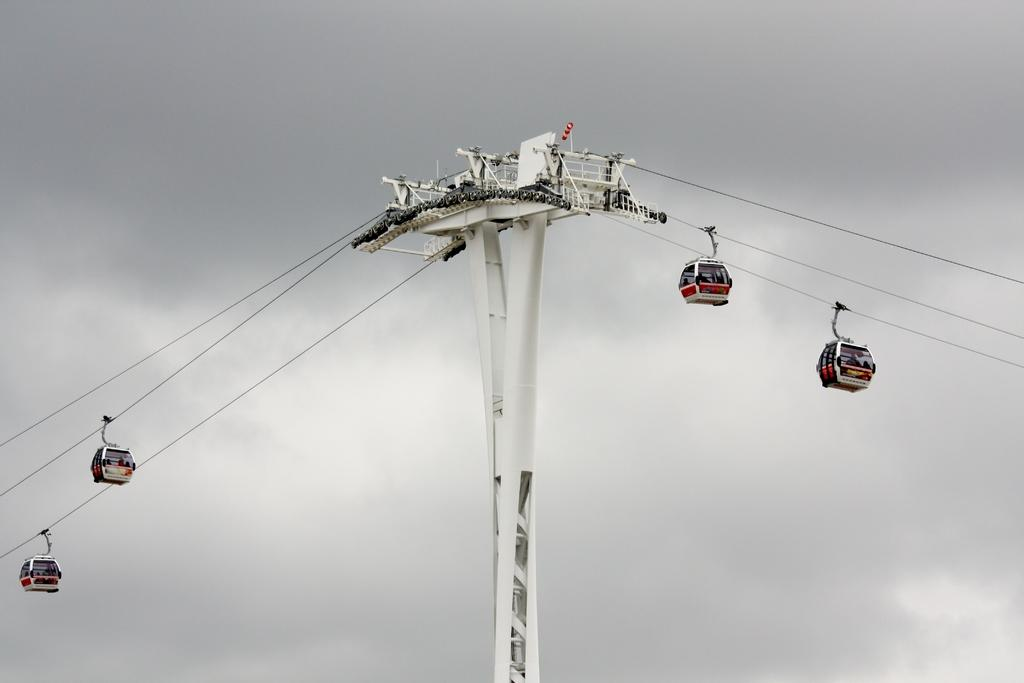What is the main structure visible in the image? There is a pole in the image. What are the people in the image doing? The people are sitting in a ropeway wheel car. What is connected to the pole in the image? There is a wire in the image. How many birds are perched on the pole in the image? There are no birds visible in the image. Is there a fireman climbing the pole in the image? There is no fireman present in the image. 